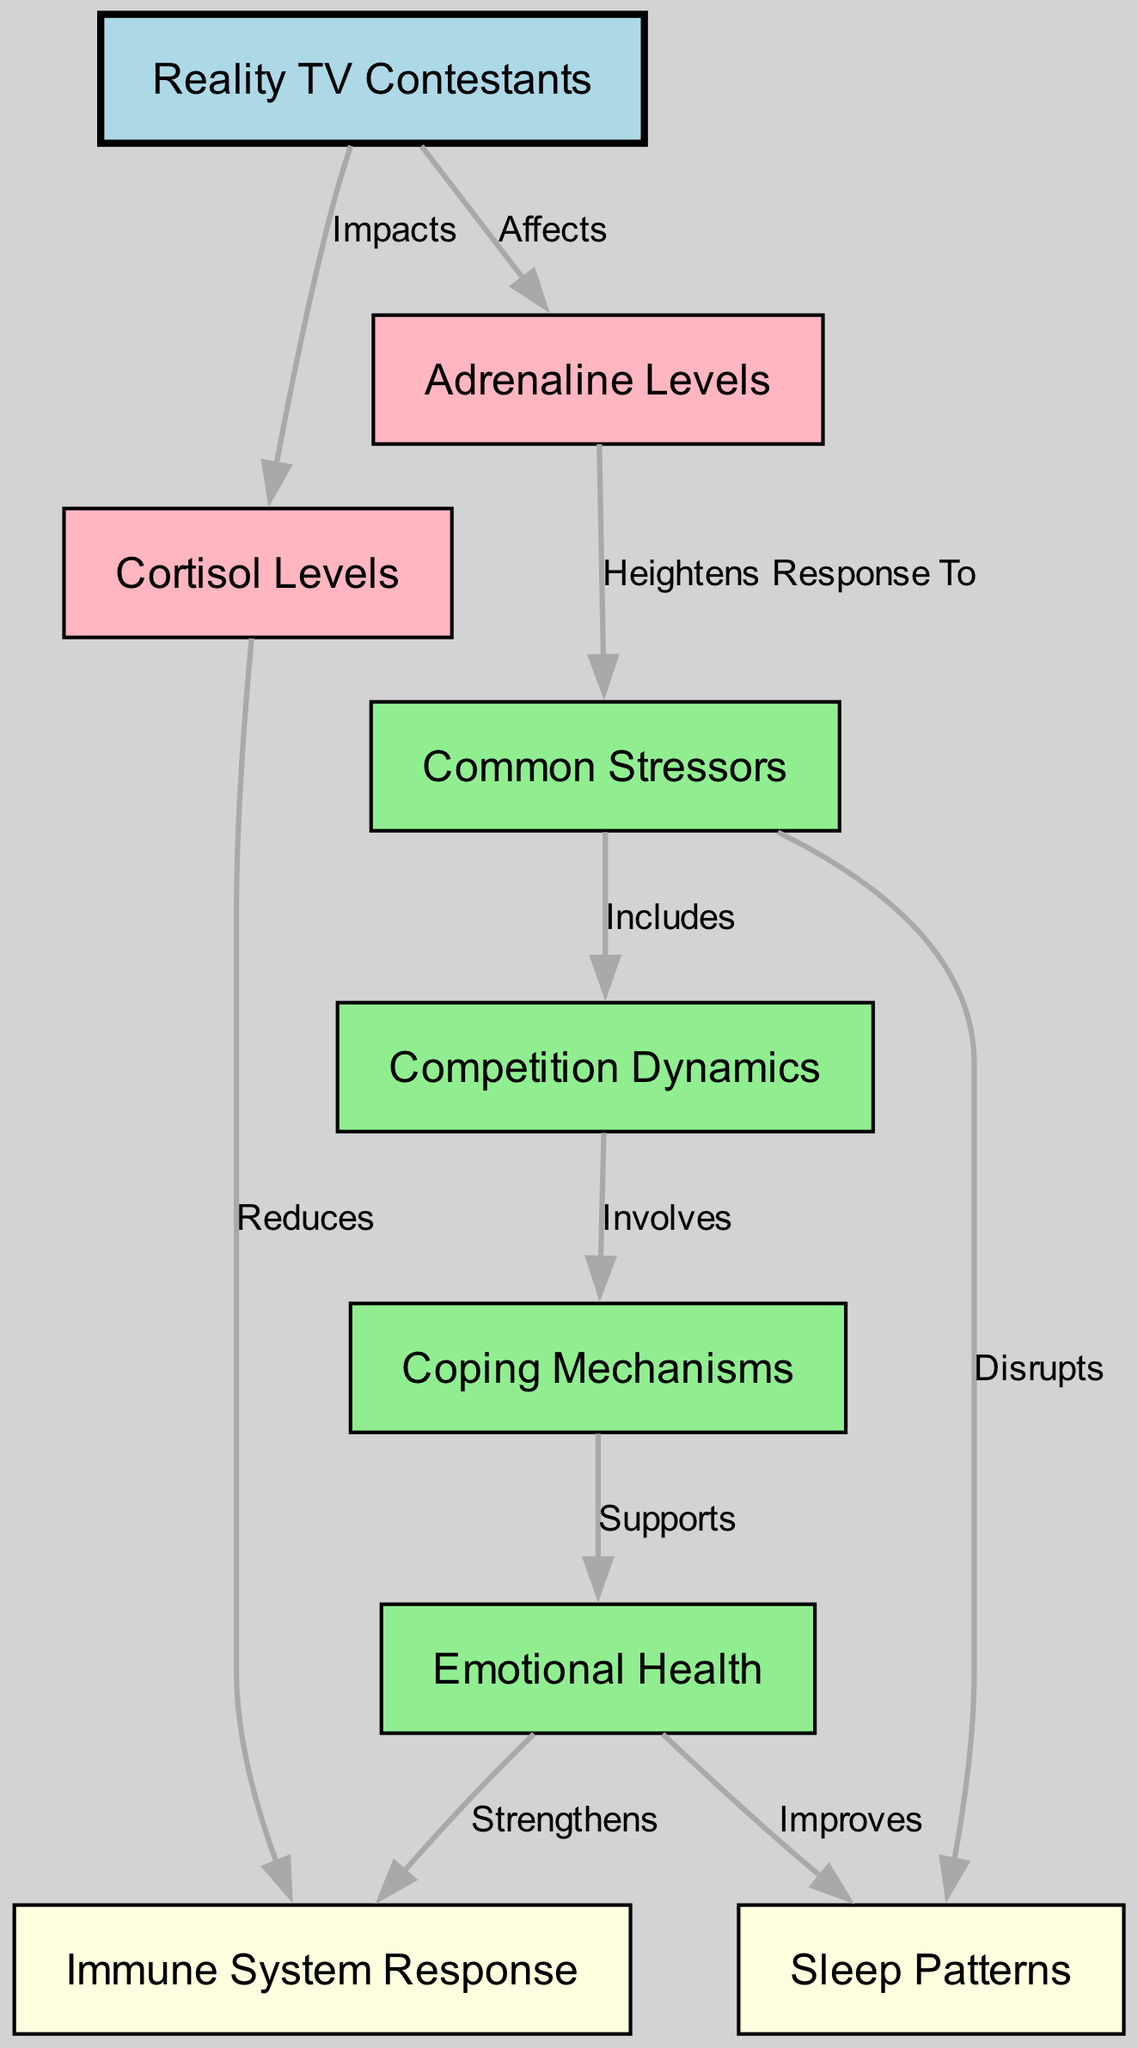What nodes are connected to Cortisol? According to the diagram, Cortisol has two outgoing connections. It impacts Contestants and reduces Immunity.
Answer: Contestants, Immunity How many nodes are in the diagram? The diagram contains a total of 9 distinct nodes, which includes both the main entities and processes related to hormonal changes and stress levels.
Answer: 9 What effect does Stressors have on Sleep Patterns? The diagram shows that Stressors disrupt Sleep Patterns, indicating a negative impact on the quality of sleep for the contestants.
Answer: Disrupts Which nodes involve the role of Competition? The Competition node has one outgoing connection that involves Coping. This implies that competition dynamics influence coping mechanisms for the contestants.
Answer: Coping How does Adrenaline relate to Stressors? Adrenaline heightens the response to Stressors, meaning that increased adrenaline levels elevate how contestants react to stressful situations they face, such as challenges or conflicts in the reality TV setting.
Answer: Heightens Response To What is the relationship between Emotional Health and Immunity? Emotional Health strengthens the Immune System Response, suggesting that participants who manage their emotional health effectively may experience better immune system functioning overall.
Answer: Strengthens What kind of stressors are included in the diagram? The diagram specifies that the Common Stressors include elements related to Competition, which reflects the various challenges and tensions contestants face while on reality TV.
Answer: Includes Which mechanisms support Emotional Health? The diagram indicates that Coping Mechanisms support Emotional Health, suggesting that effective coping strategies can lead to improved emotional well-being in the contestants.
Answer: Supports 